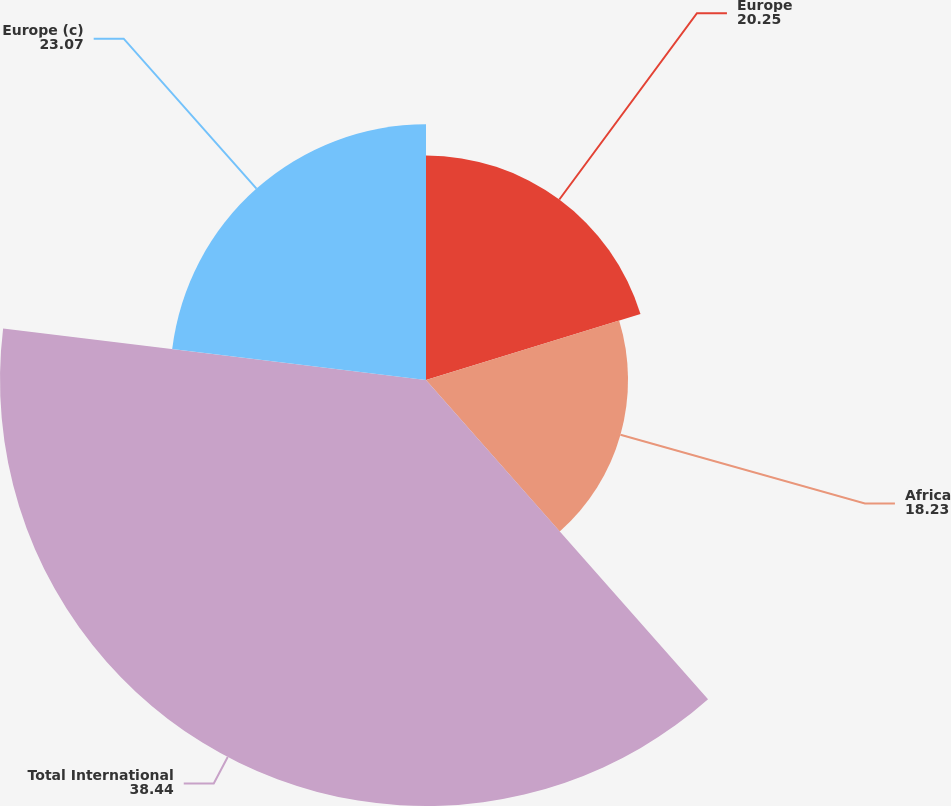Convert chart. <chart><loc_0><loc_0><loc_500><loc_500><pie_chart><fcel>Europe<fcel>Africa<fcel>Total International<fcel>Europe (c)<nl><fcel>20.25%<fcel>18.23%<fcel>38.44%<fcel>23.07%<nl></chart> 